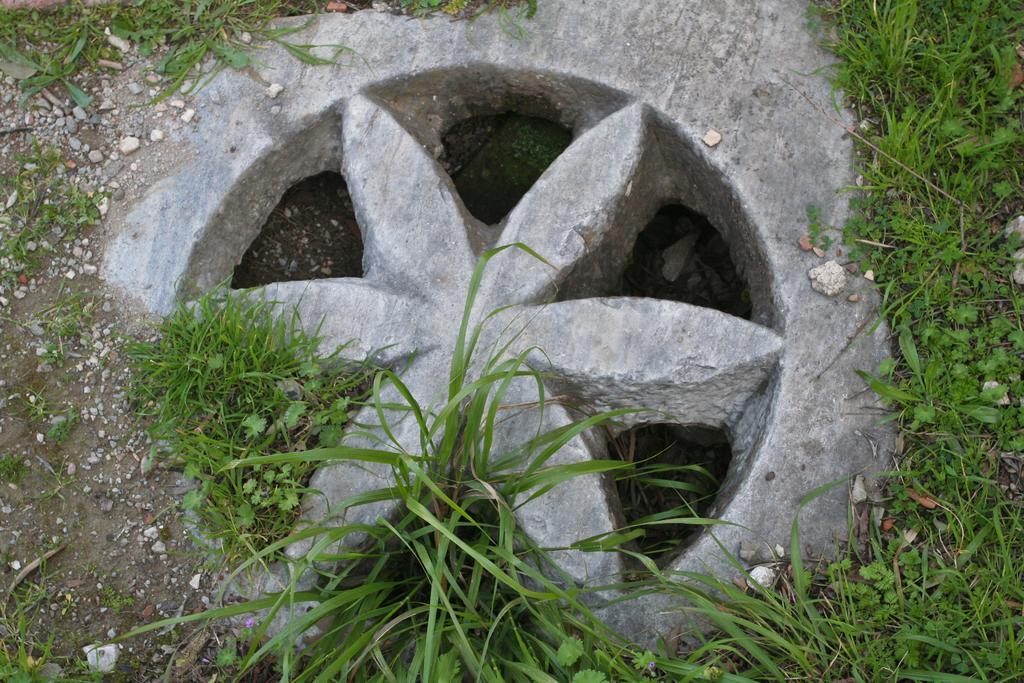Can you describe this image briefly? This image consists of a stone in the shape of flower is kept on the ground. Beside that there is green grass on the ground. 